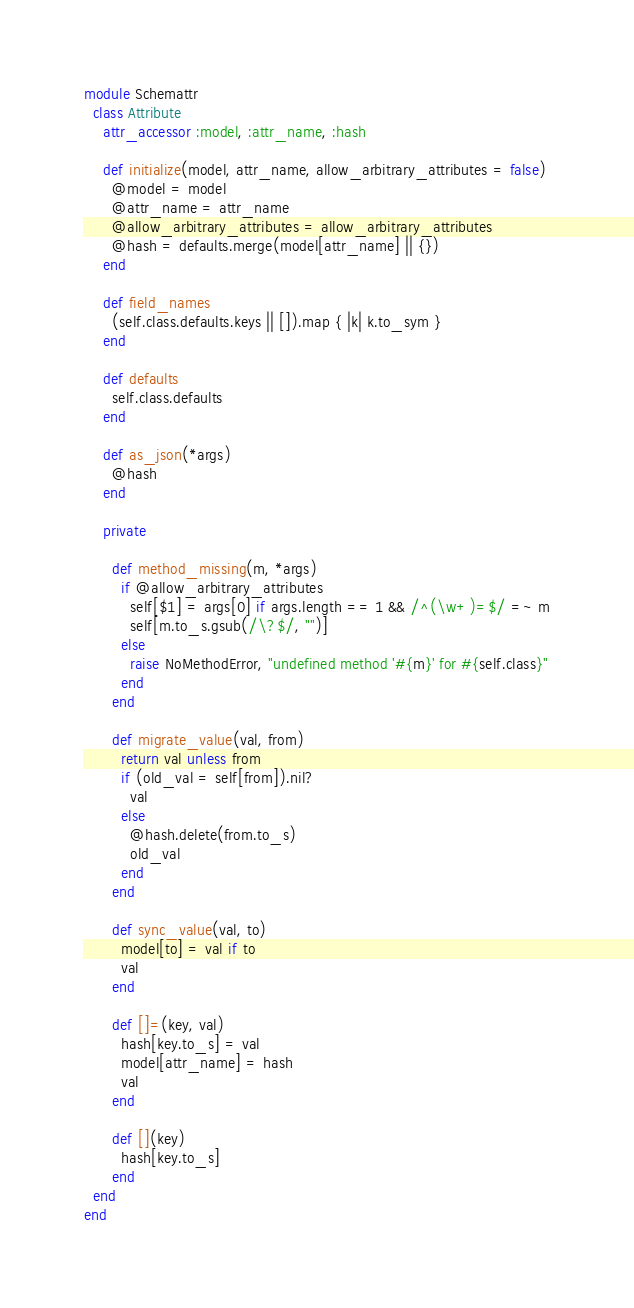<code> <loc_0><loc_0><loc_500><loc_500><_Ruby_>module Schemattr
  class Attribute
    attr_accessor :model, :attr_name, :hash

    def initialize(model, attr_name, allow_arbitrary_attributes = false)
      @model = model
      @attr_name = attr_name
      @allow_arbitrary_attributes = allow_arbitrary_attributes
      @hash = defaults.merge(model[attr_name] || {})
    end

    def field_names
      (self.class.defaults.keys || []).map { |k| k.to_sym }
    end

    def defaults
      self.class.defaults
    end

    def as_json(*args)
      @hash
    end

    private

      def method_missing(m, *args)
        if @allow_arbitrary_attributes
          self[$1] = args[0] if args.length == 1 && /^(\w+)=$/ =~ m
          self[m.to_s.gsub(/\?$/, "")]
        else
          raise NoMethodError, "undefined method '#{m}' for #{self.class}"
        end
      end

      def migrate_value(val, from)
        return val unless from
        if (old_val = self[from]).nil?
          val
        else
          @hash.delete(from.to_s)
          old_val
        end
      end

      def sync_value(val, to)
        model[to] = val if to
        val
      end

      def []=(key, val)
        hash[key.to_s] = val
        model[attr_name] = hash
        val
      end

      def [](key)
        hash[key.to_s]
      end
  end
end
</code> 